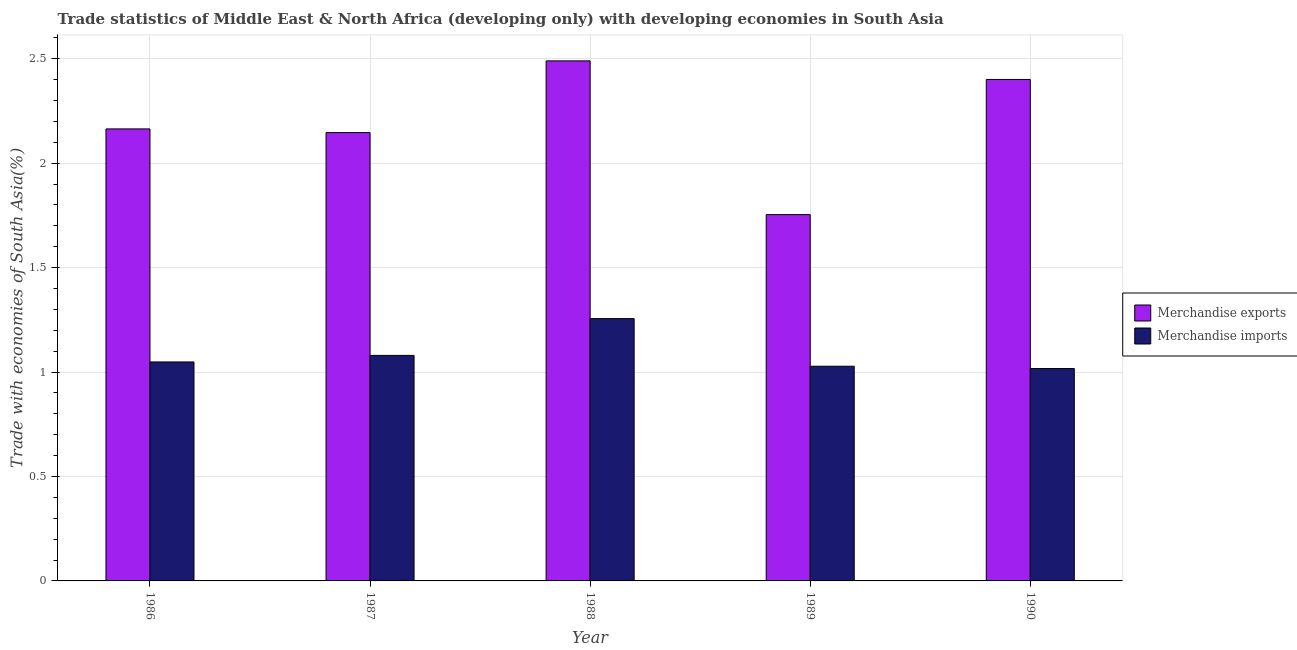How many groups of bars are there?
Provide a succinct answer. 5. Are the number of bars on each tick of the X-axis equal?
Your answer should be very brief. Yes. How many bars are there on the 5th tick from the left?
Offer a very short reply. 2. How many bars are there on the 4th tick from the right?
Offer a very short reply. 2. In how many cases, is the number of bars for a given year not equal to the number of legend labels?
Offer a terse response. 0. What is the merchandise imports in 1989?
Make the answer very short. 1.03. Across all years, what is the maximum merchandise exports?
Provide a succinct answer. 2.49. Across all years, what is the minimum merchandise exports?
Offer a terse response. 1.75. In which year was the merchandise imports maximum?
Provide a succinct answer. 1988. What is the total merchandise exports in the graph?
Offer a very short reply. 10.95. What is the difference between the merchandise imports in 1986 and that in 1989?
Offer a terse response. 0.02. What is the difference between the merchandise imports in 1987 and the merchandise exports in 1989?
Your answer should be compact. 0.05. What is the average merchandise exports per year?
Give a very brief answer. 2.19. In the year 1989, what is the difference between the merchandise exports and merchandise imports?
Make the answer very short. 0. What is the ratio of the merchandise imports in 1988 to that in 1989?
Provide a short and direct response. 1.22. Is the merchandise imports in 1986 less than that in 1989?
Keep it short and to the point. No. What is the difference between the highest and the second highest merchandise imports?
Give a very brief answer. 0.18. What is the difference between the highest and the lowest merchandise exports?
Ensure brevity in your answer.  0.74. What does the 2nd bar from the left in 1986 represents?
Your answer should be very brief. Merchandise imports. What does the 2nd bar from the right in 1986 represents?
Provide a short and direct response. Merchandise exports. How many bars are there?
Your answer should be compact. 10. How many years are there in the graph?
Your response must be concise. 5. What is the title of the graph?
Ensure brevity in your answer.  Trade statistics of Middle East & North Africa (developing only) with developing economies in South Asia. Does "Import" appear as one of the legend labels in the graph?
Offer a very short reply. No. What is the label or title of the Y-axis?
Your response must be concise. Trade with economies of South Asia(%). What is the Trade with economies of South Asia(%) of Merchandise exports in 1986?
Your response must be concise. 2.16. What is the Trade with economies of South Asia(%) of Merchandise imports in 1986?
Your answer should be compact. 1.05. What is the Trade with economies of South Asia(%) in Merchandise exports in 1987?
Provide a succinct answer. 2.15. What is the Trade with economies of South Asia(%) of Merchandise imports in 1987?
Make the answer very short. 1.08. What is the Trade with economies of South Asia(%) in Merchandise exports in 1988?
Provide a short and direct response. 2.49. What is the Trade with economies of South Asia(%) in Merchandise imports in 1988?
Provide a succinct answer. 1.26. What is the Trade with economies of South Asia(%) of Merchandise exports in 1989?
Your answer should be compact. 1.75. What is the Trade with economies of South Asia(%) in Merchandise imports in 1989?
Your answer should be very brief. 1.03. What is the Trade with economies of South Asia(%) of Merchandise exports in 1990?
Ensure brevity in your answer.  2.4. What is the Trade with economies of South Asia(%) of Merchandise imports in 1990?
Your answer should be compact. 1.02. Across all years, what is the maximum Trade with economies of South Asia(%) of Merchandise exports?
Make the answer very short. 2.49. Across all years, what is the maximum Trade with economies of South Asia(%) in Merchandise imports?
Offer a terse response. 1.26. Across all years, what is the minimum Trade with economies of South Asia(%) in Merchandise exports?
Give a very brief answer. 1.75. Across all years, what is the minimum Trade with economies of South Asia(%) in Merchandise imports?
Make the answer very short. 1.02. What is the total Trade with economies of South Asia(%) of Merchandise exports in the graph?
Provide a succinct answer. 10.95. What is the total Trade with economies of South Asia(%) of Merchandise imports in the graph?
Your answer should be very brief. 5.43. What is the difference between the Trade with economies of South Asia(%) of Merchandise exports in 1986 and that in 1987?
Your answer should be compact. 0.02. What is the difference between the Trade with economies of South Asia(%) in Merchandise imports in 1986 and that in 1987?
Give a very brief answer. -0.03. What is the difference between the Trade with economies of South Asia(%) in Merchandise exports in 1986 and that in 1988?
Offer a terse response. -0.33. What is the difference between the Trade with economies of South Asia(%) of Merchandise imports in 1986 and that in 1988?
Make the answer very short. -0.21. What is the difference between the Trade with economies of South Asia(%) in Merchandise exports in 1986 and that in 1989?
Provide a succinct answer. 0.41. What is the difference between the Trade with economies of South Asia(%) of Merchandise imports in 1986 and that in 1989?
Provide a short and direct response. 0.02. What is the difference between the Trade with economies of South Asia(%) in Merchandise exports in 1986 and that in 1990?
Offer a terse response. -0.24. What is the difference between the Trade with economies of South Asia(%) of Merchandise imports in 1986 and that in 1990?
Make the answer very short. 0.03. What is the difference between the Trade with economies of South Asia(%) in Merchandise exports in 1987 and that in 1988?
Your answer should be very brief. -0.34. What is the difference between the Trade with economies of South Asia(%) of Merchandise imports in 1987 and that in 1988?
Your answer should be very brief. -0.18. What is the difference between the Trade with economies of South Asia(%) of Merchandise exports in 1987 and that in 1989?
Offer a terse response. 0.39. What is the difference between the Trade with economies of South Asia(%) in Merchandise imports in 1987 and that in 1989?
Ensure brevity in your answer.  0.05. What is the difference between the Trade with economies of South Asia(%) in Merchandise exports in 1987 and that in 1990?
Ensure brevity in your answer.  -0.25. What is the difference between the Trade with economies of South Asia(%) in Merchandise imports in 1987 and that in 1990?
Your response must be concise. 0.06. What is the difference between the Trade with economies of South Asia(%) in Merchandise exports in 1988 and that in 1989?
Offer a terse response. 0.74. What is the difference between the Trade with economies of South Asia(%) in Merchandise imports in 1988 and that in 1989?
Offer a very short reply. 0.23. What is the difference between the Trade with economies of South Asia(%) in Merchandise exports in 1988 and that in 1990?
Your answer should be very brief. 0.09. What is the difference between the Trade with economies of South Asia(%) of Merchandise imports in 1988 and that in 1990?
Offer a terse response. 0.24. What is the difference between the Trade with economies of South Asia(%) in Merchandise exports in 1989 and that in 1990?
Your answer should be compact. -0.65. What is the difference between the Trade with economies of South Asia(%) in Merchandise imports in 1989 and that in 1990?
Make the answer very short. 0.01. What is the difference between the Trade with economies of South Asia(%) in Merchandise exports in 1986 and the Trade with economies of South Asia(%) in Merchandise imports in 1987?
Your answer should be very brief. 1.08. What is the difference between the Trade with economies of South Asia(%) in Merchandise exports in 1986 and the Trade with economies of South Asia(%) in Merchandise imports in 1988?
Keep it short and to the point. 0.91. What is the difference between the Trade with economies of South Asia(%) of Merchandise exports in 1986 and the Trade with economies of South Asia(%) of Merchandise imports in 1989?
Offer a terse response. 1.14. What is the difference between the Trade with economies of South Asia(%) of Merchandise exports in 1986 and the Trade with economies of South Asia(%) of Merchandise imports in 1990?
Provide a succinct answer. 1.15. What is the difference between the Trade with economies of South Asia(%) in Merchandise exports in 1987 and the Trade with economies of South Asia(%) in Merchandise imports in 1988?
Your response must be concise. 0.89. What is the difference between the Trade with economies of South Asia(%) in Merchandise exports in 1987 and the Trade with economies of South Asia(%) in Merchandise imports in 1989?
Give a very brief answer. 1.12. What is the difference between the Trade with economies of South Asia(%) in Merchandise exports in 1987 and the Trade with economies of South Asia(%) in Merchandise imports in 1990?
Keep it short and to the point. 1.13. What is the difference between the Trade with economies of South Asia(%) in Merchandise exports in 1988 and the Trade with economies of South Asia(%) in Merchandise imports in 1989?
Offer a very short reply. 1.46. What is the difference between the Trade with economies of South Asia(%) in Merchandise exports in 1988 and the Trade with economies of South Asia(%) in Merchandise imports in 1990?
Give a very brief answer. 1.47. What is the difference between the Trade with economies of South Asia(%) of Merchandise exports in 1989 and the Trade with economies of South Asia(%) of Merchandise imports in 1990?
Keep it short and to the point. 0.74. What is the average Trade with economies of South Asia(%) in Merchandise exports per year?
Your response must be concise. 2.19. What is the average Trade with economies of South Asia(%) in Merchandise imports per year?
Make the answer very short. 1.09. In the year 1986, what is the difference between the Trade with economies of South Asia(%) in Merchandise exports and Trade with economies of South Asia(%) in Merchandise imports?
Provide a succinct answer. 1.12. In the year 1987, what is the difference between the Trade with economies of South Asia(%) of Merchandise exports and Trade with economies of South Asia(%) of Merchandise imports?
Ensure brevity in your answer.  1.07. In the year 1988, what is the difference between the Trade with economies of South Asia(%) in Merchandise exports and Trade with economies of South Asia(%) in Merchandise imports?
Your answer should be compact. 1.23. In the year 1989, what is the difference between the Trade with economies of South Asia(%) of Merchandise exports and Trade with economies of South Asia(%) of Merchandise imports?
Offer a terse response. 0.73. In the year 1990, what is the difference between the Trade with economies of South Asia(%) in Merchandise exports and Trade with economies of South Asia(%) in Merchandise imports?
Make the answer very short. 1.38. What is the ratio of the Trade with economies of South Asia(%) in Merchandise exports in 1986 to that in 1987?
Provide a succinct answer. 1.01. What is the ratio of the Trade with economies of South Asia(%) of Merchandise imports in 1986 to that in 1987?
Provide a succinct answer. 0.97. What is the ratio of the Trade with economies of South Asia(%) of Merchandise exports in 1986 to that in 1988?
Give a very brief answer. 0.87. What is the ratio of the Trade with economies of South Asia(%) of Merchandise imports in 1986 to that in 1988?
Make the answer very short. 0.83. What is the ratio of the Trade with economies of South Asia(%) in Merchandise exports in 1986 to that in 1989?
Offer a very short reply. 1.23. What is the ratio of the Trade with economies of South Asia(%) of Merchandise imports in 1986 to that in 1989?
Make the answer very short. 1.02. What is the ratio of the Trade with economies of South Asia(%) in Merchandise exports in 1986 to that in 1990?
Your answer should be very brief. 0.9. What is the ratio of the Trade with economies of South Asia(%) of Merchandise imports in 1986 to that in 1990?
Your answer should be very brief. 1.03. What is the ratio of the Trade with economies of South Asia(%) of Merchandise exports in 1987 to that in 1988?
Give a very brief answer. 0.86. What is the ratio of the Trade with economies of South Asia(%) in Merchandise imports in 1987 to that in 1988?
Keep it short and to the point. 0.86. What is the ratio of the Trade with economies of South Asia(%) of Merchandise exports in 1987 to that in 1989?
Give a very brief answer. 1.22. What is the ratio of the Trade with economies of South Asia(%) in Merchandise imports in 1987 to that in 1989?
Your response must be concise. 1.05. What is the ratio of the Trade with economies of South Asia(%) in Merchandise exports in 1987 to that in 1990?
Offer a very short reply. 0.89. What is the ratio of the Trade with economies of South Asia(%) in Merchandise imports in 1987 to that in 1990?
Make the answer very short. 1.06. What is the ratio of the Trade with economies of South Asia(%) of Merchandise exports in 1988 to that in 1989?
Provide a succinct answer. 1.42. What is the ratio of the Trade with economies of South Asia(%) in Merchandise imports in 1988 to that in 1989?
Give a very brief answer. 1.22. What is the ratio of the Trade with economies of South Asia(%) in Merchandise exports in 1988 to that in 1990?
Keep it short and to the point. 1.04. What is the ratio of the Trade with economies of South Asia(%) of Merchandise imports in 1988 to that in 1990?
Offer a very short reply. 1.23. What is the ratio of the Trade with economies of South Asia(%) in Merchandise exports in 1989 to that in 1990?
Your answer should be compact. 0.73. What is the ratio of the Trade with economies of South Asia(%) of Merchandise imports in 1989 to that in 1990?
Keep it short and to the point. 1.01. What is the difference between the highest and the second highest Trade with economies of South Asia(%) in Merchandise exports?
Make the answer very short. 0.09. What is the difference between the highest and the second highest Trade with economies of South Asia(%) of Merchandise imports?
Provide a succinct answer. 0.18. What is the difference between the highest and the lowest Trade with economies of South Asia(%) in Merchandise exports?
Your answer should be very brief. 0.74. What is the difference between the highest and the lowest Trade with economies of South Asia(%) in Merchandise imports?
Make the answer very short. 0.24. 